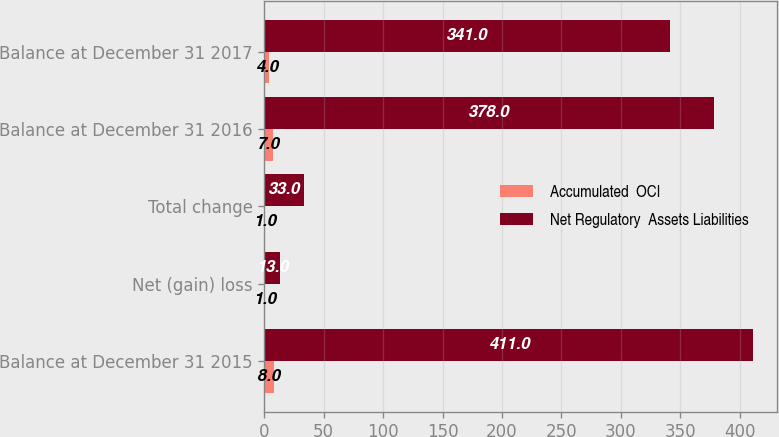Convert chart to OTSL. <chart><loc_0><loc_0><loc_500><loc_500><stacked_bar_chart><ecel><fcel>Balance at December 31 2015<fcel>Net (gain) loss<fcel>Total change<fcel>Balance at December 31 2016<fcel>Balance at December 31 2017<nl><fcel>Accumulated  OCI<fcel>8<fcel>1<fcel>1<fcel>7<fcel>4<nl><fcel>Net Regulatory  Assets Liabilities<fcel>411<fcel>13<fcel>33<fcel>378<fcel>341<nl></chart> 